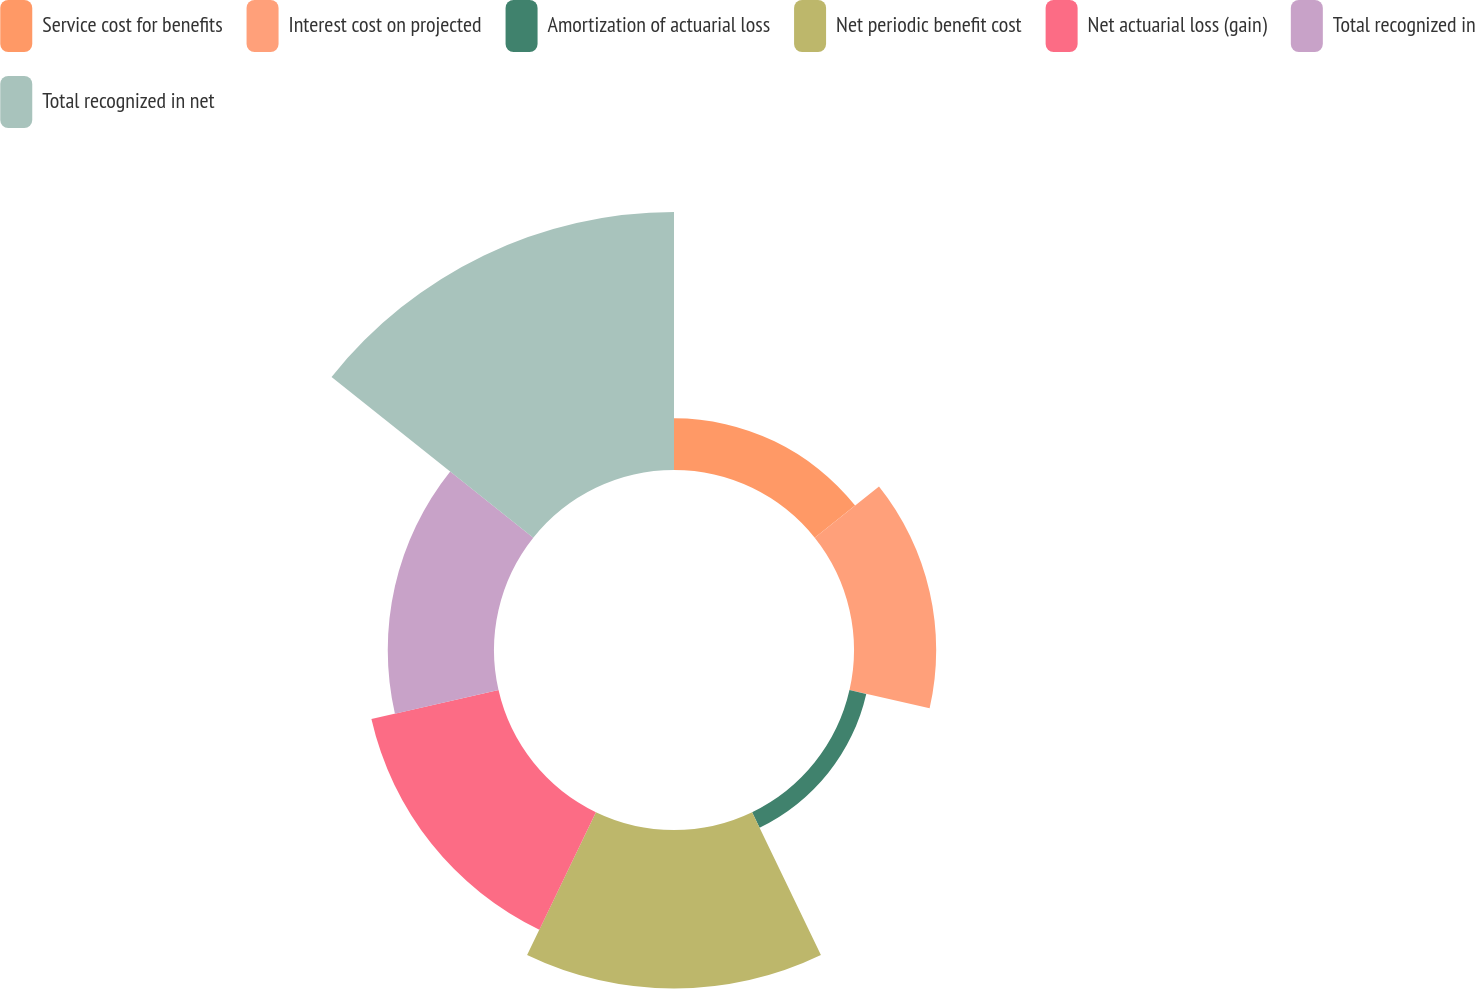Convert chart to OTSL. <chart><loc_0><loc_0><loc_500><loc_500><pie_chart><fcel>Service cost for benefits<fcel>Interest cost on projected<fcel>Amortization of actuarial loss<fcel>Net periodic benefit cost<fcel>Net actuarial loss (gain)<fcel>Total recognized in<fcel>Total recognized in net<nl><fcel>6.42%<fcel>10.22%<fcel>2.14%<fcel>19.72%<fcel>16.21%<fcel>13.21%<fcel>32.08%<nl></chart> 